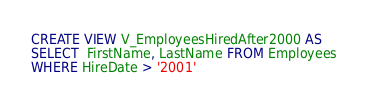Convert code to text. <code><loc_0><loc_0><loc_500><loc_500><_SQL_>CREATE VIEW V_EmployeesHiredAfter2000 AS
SELECT  FirstName, LastName FROM Employees
WHERE HireDate > '2001'</code> 